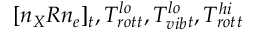<formula> <loc_0><loc_0><loc_500><loc_500>[ n _ { X } R n _ { e } ] _ { t } , T _ { r o t } ^ { l o } { _ { t } } , T _ { v i b } ^ { l o } { _ { t } } , T _ { r o t } ^ { h i } { _ { t } }</formula> 